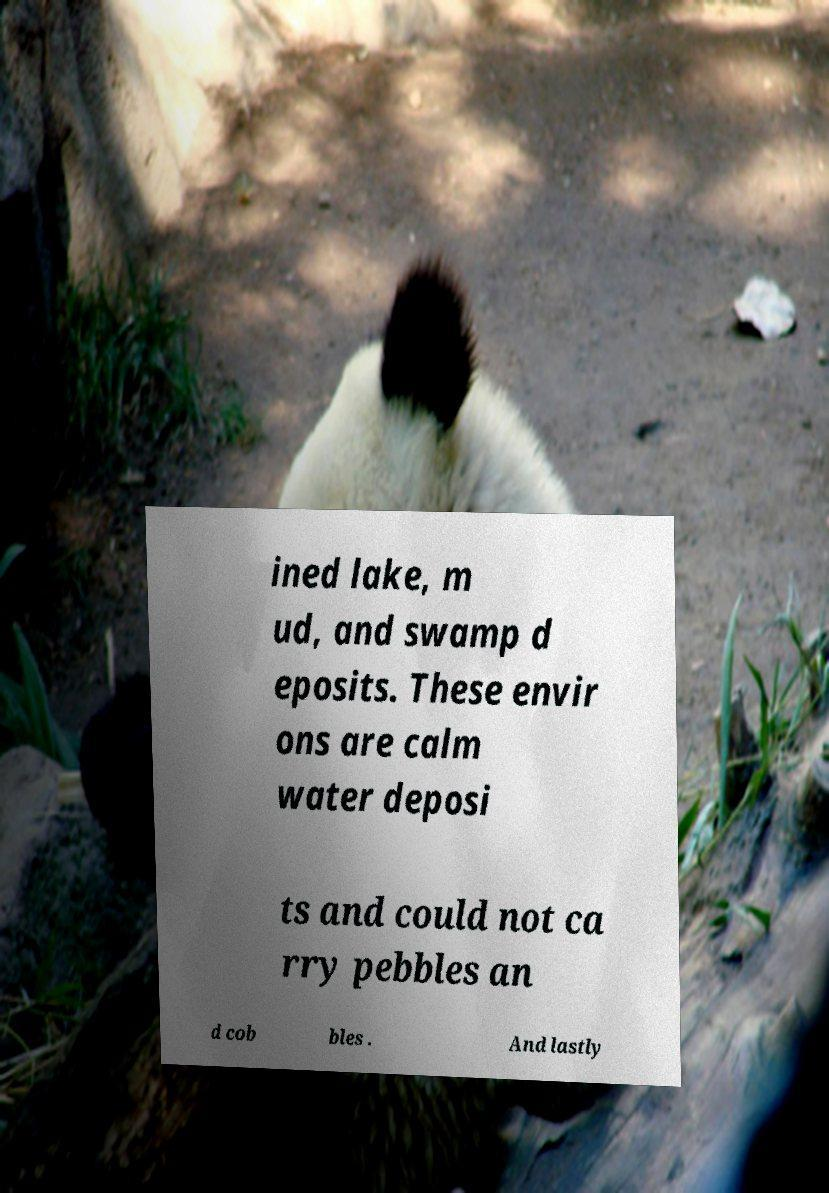I need the written content from this picture converted into text. Can you do that? ined lake, m ud, and swamp d eposits. These envir ons are calm water deposi ts and could not ca rry pebbles an d cob bles . And lastly 